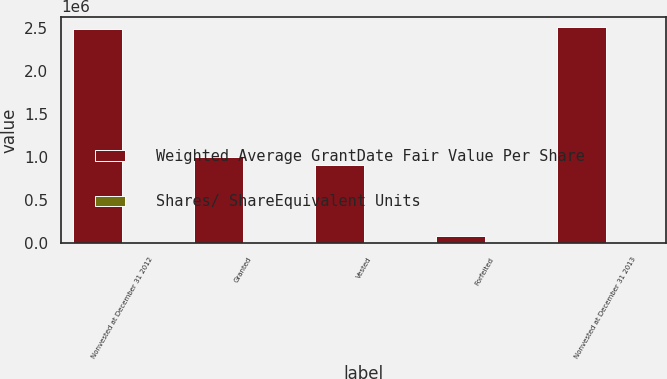Convert chart. <chart><loc_0><loc_0><loc_500><loc_500><stacked_bar_chart><ecel><fcel>Nonvested at December 31 2012<fcel>Granted<fcel>Vested<fcel>Forfeited<fcel>Nonvested at December 31 2013<nl><fcel>Weighted Average GrantDate Fair Value Per Share<fcel>2.49345e+06<fcel>1.00054e+06<fcel>903731<fcel>82862<fcel>2.5074e+06<nl><fcel>Shares/ ShareEquivalent Units<fcel>61.23<fcel>67.99<fcel>40.46<fcel>70.33<fcel>71.11<nl></chart> 